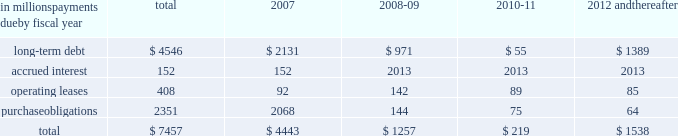Guarantees to third parties .
We have , however , issued guar- antees and comfort letters of $ 171 million for the debt and other obligations of unconsolidated affiliates , primarily for cpw .
In addition , off-balance sheet arrangements are gener- ally limited to the future payments under noncancelable operating leases , which totaled $ 408 million at may 28 , at may 28 , 2006 , we had invested in four variable interest entities ( vies ) .
We are the primary beneficiary ( pb ) of general mills capital , inc .
( gm capital ) , a subsidiary that we consolidate as set forth in note eight to the consoli- dated financial statements appearing on pages 43 and 44 in item eight of this report .
We also have an interest in a contract manufacturer at our former facility in geneva , illi- nois .
Even though we are the pb , we have not consolidated this entity because it is not material to our results of oper- ations , financial condition , or liquidity at may 28 , 2006 .
This entity had property and equipment of $ 50 million and long-term debt of $ 50 million at may 28 , 2006 .
We are not the pb of the remaining two vies .
Our maximum exposure to loss from these vies is limited to the $ 150 million minority interest in gm capital , the contract manufactur- er 2019s debt and our $ 6 million of equity investments in the two remaining vies .
The table summarizes our future estimated cash payments under existing contractual obligations , including payments due by period .
The majority of the purchase obligations represent commitments for raw mate- rial and packaging to be utilized in the normal course of business and for consumer-directed marketing commit- ments that support our brands .
The net fair value of our interest rate and equity swaps was $ 159 million at may 28 , 2006 , based on market values as of that date .
Future changes in market values will impact the amount of cash ultimately paid or received to settle those instruments in the future .
Other long-term obligations primarily consist of income taxes , accrued compensation and benefits , and miscella- neous liabilities .
We are unable to estimate the timing of the payments for these items .
We do not have significant statutory or contractual funding requirements for our defined-benefit retirement and other postretirement benefit plans .
Further information on these plans , including our expected contributions for fiscal 2007 , is set forth in note thirteen to the consolidated financial statements appearing on pages 47 through 50 in item eight of this report .
In millions , payments due by fiscal year total 2007 2008-09 2010-11 2012 and thereafter .
Significant accounting estimates for a complete description of our significant accounting policies , please see note one to the consolidated financial statements appearing on pages 35 through 37 in item eight of this report .
Our significant accounting estimates are those that have meaningful impact on the reporting of our financial condition and results of operations .
These poli- cies include our accounting for trade and consumer promotion activities ; goodwill and other intangible asset impairments ; income taxes ; and pension and other postretirement benefits .
Trade and consumer promotion activities we report sales net of certain coupon and trade promotion costs .
The consumer coupon costs recorded as a reduction of sales are based on the estimated redemption value of those coupons , as determined by historical patterns of coupon redemption and consideration of current market conditions such as competitive activity in those product categories .
The trade promotion costs include payments to customers to perform merchandising activities on our behalf , such as advertising or in-store displays , discounts to our list prices to lower retail shelf prices , and payments to gain distribution of new products .
The cost of these activi- ties is recognized as the related revenue is recorded , which generally precedes the actual cash expenditure .
The recog- nition of these costs requires estimation of customer participation and performance levels .
These estimates are made based on the quantity of customer sales , the timing and forecasted costs of promotional activities , and other factors .
Differences between estimated expenses and actual costs are normally insignificant and are recognized as a change in management estimate in a subsequent period .
Our accrued trade and consumer promotion liability was $ 339 million as of may 28 , 2006 , and $ 283 million as of may 29 , 2005 .
Our unit volume in the last week of each quarter is consis- tently higher than the average for the preceding weeks of the quarter .
In comparison to the average daily shipments in the first 12 weeks of a quarter , the final week of each quarter has approximately two to four days 2019 worth of incre- mental shipments ( based on a five-day week ) , reflecting increased promotional activity at the end of the quarter .
This increased activity includes promotions to assure that our customers have sufficient inventory on hand to support major marketing events or increased seasonal demand early in the next quarter , as well as promotions intended to help achieve interim unit volume targets .
If , due to quarter-end promotions or other reasons , our customers purchase more product in any reporting period than end-consumer demand will require in future periods , our sales level in future reporting periods could be adversely affected. .
What was the percentage change in our accrued trade and consumer promotion liability from 2005 to 2006? 
Computations: ((339 - 283) / 283)
Answer: 0.19788. 